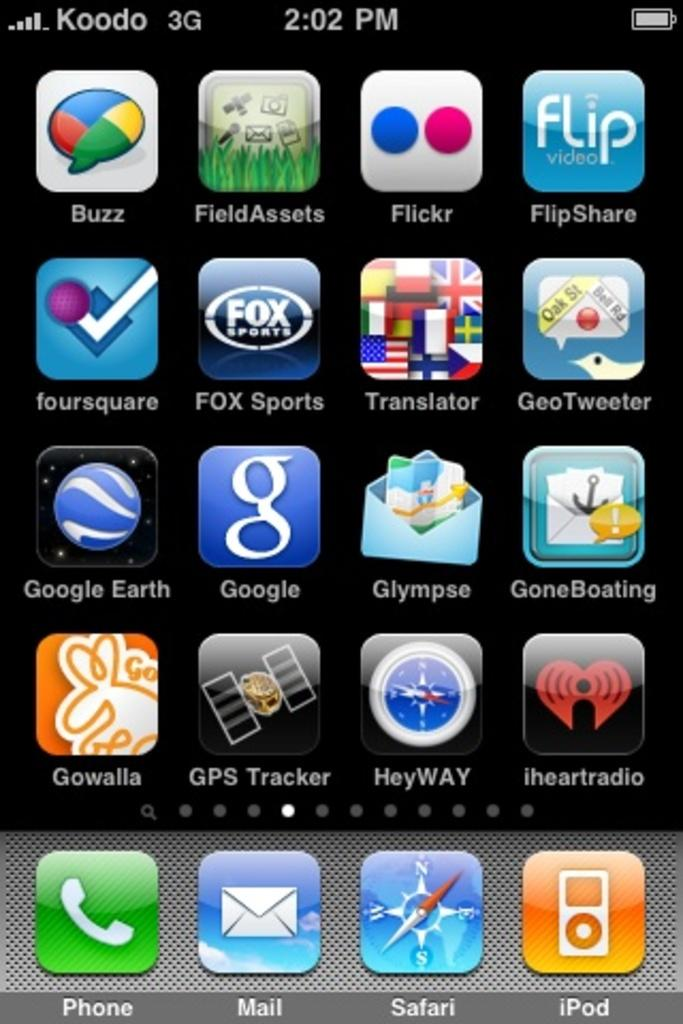<image>
Share a concise interpretation of the image provided. A Koodo brand phone open to a page full of apps. 